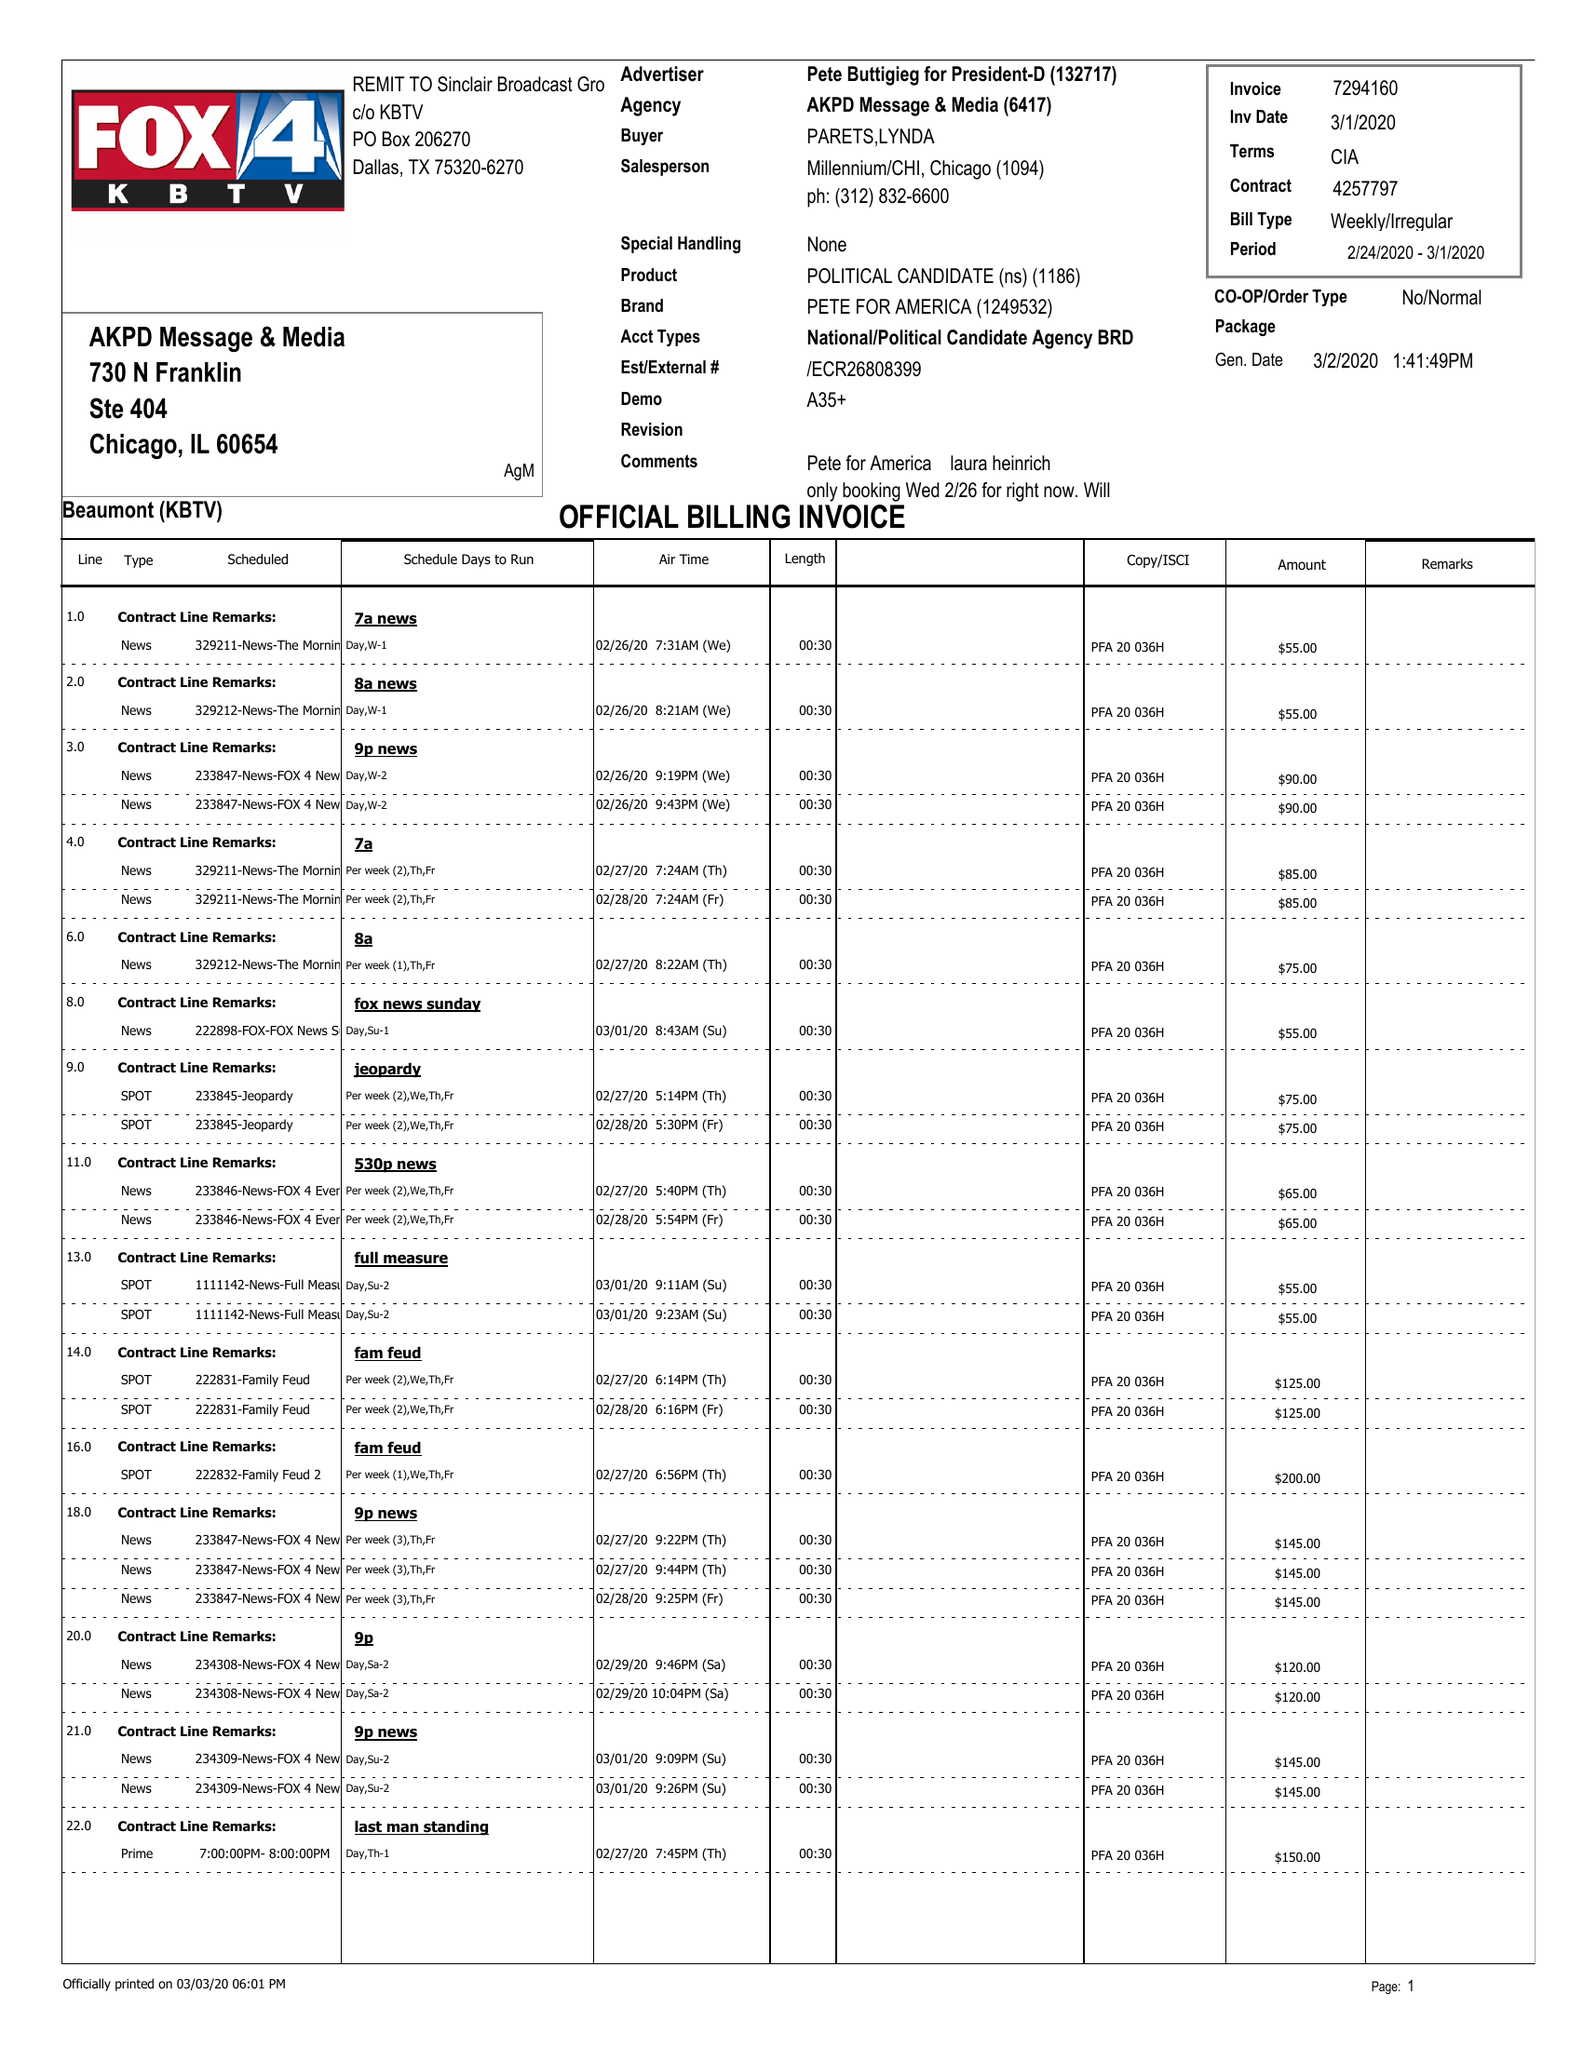What is the value for the contract_num?
Answer the question using a single word or phrase. 4257797 